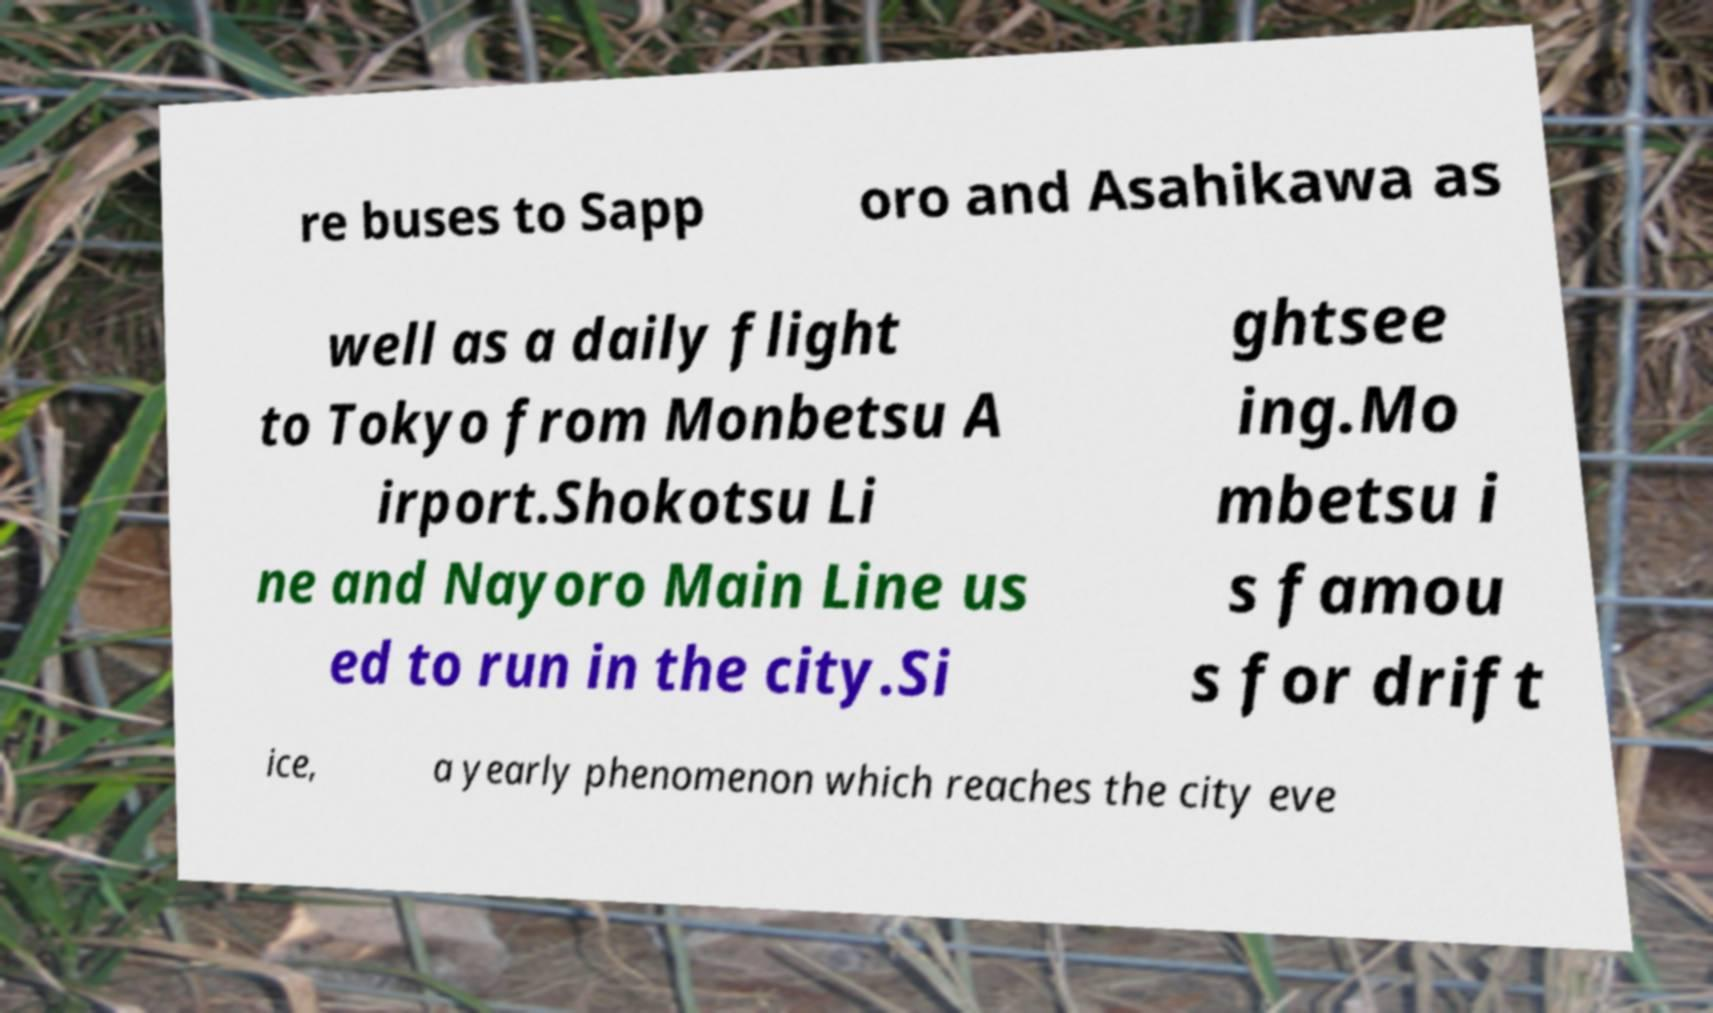For documentation purposes, I need the text within this image transcribed. Could you provide that? re buses to Sapp oro and Asahikawa as well as a daily flight to Tokyo from Monbetsu A irport.Shokotsu Li ne and Nayoro Main Line us ed to run in the city.Si ghtsee ing.Mo mbetsu i s famou s for drift ice, a yearly phenomenon which reaches the city eve 